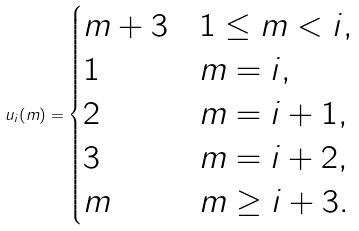Convert formula to latex. <formula><loc_0><loc_0><loc_500><loc_500>u _ { i } ( m ) = \begin{cases} m + 3 & 1 \leq m < i , \\ 1 & m = i , \\ 2 & m = i + 1 , \\ 3 & m = i + 2 , \\ m & m \geq i + 3 . \end{cases}</formula> 